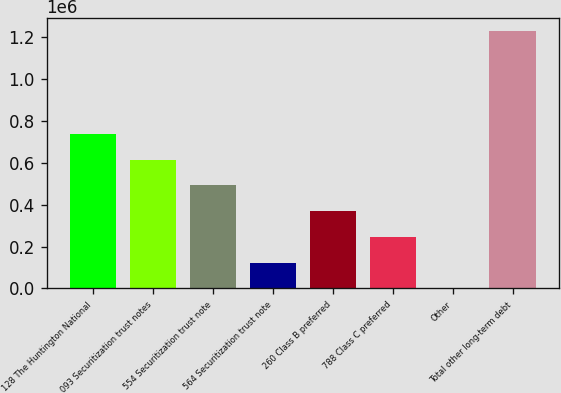Convert chart. <chart><loc_0><loc_0><loc_500><loc_500><bar_chart><fcel>128 The Huntington National<fcel>093 Securitization trust notes<fcel>554 Securitization trust note<fcel>564 Securitization trust note<fcel>260 Class B preferred<fcel>788 Class C preferred<fcel>Other<fcel>Total other long-term debt<nl><fcel>738975<fcel>615839<fcel>492703<fcel>123297<fcel>369568<fcel>246432<fcel>161<fcel>1.23152e+06<nl></chart> 